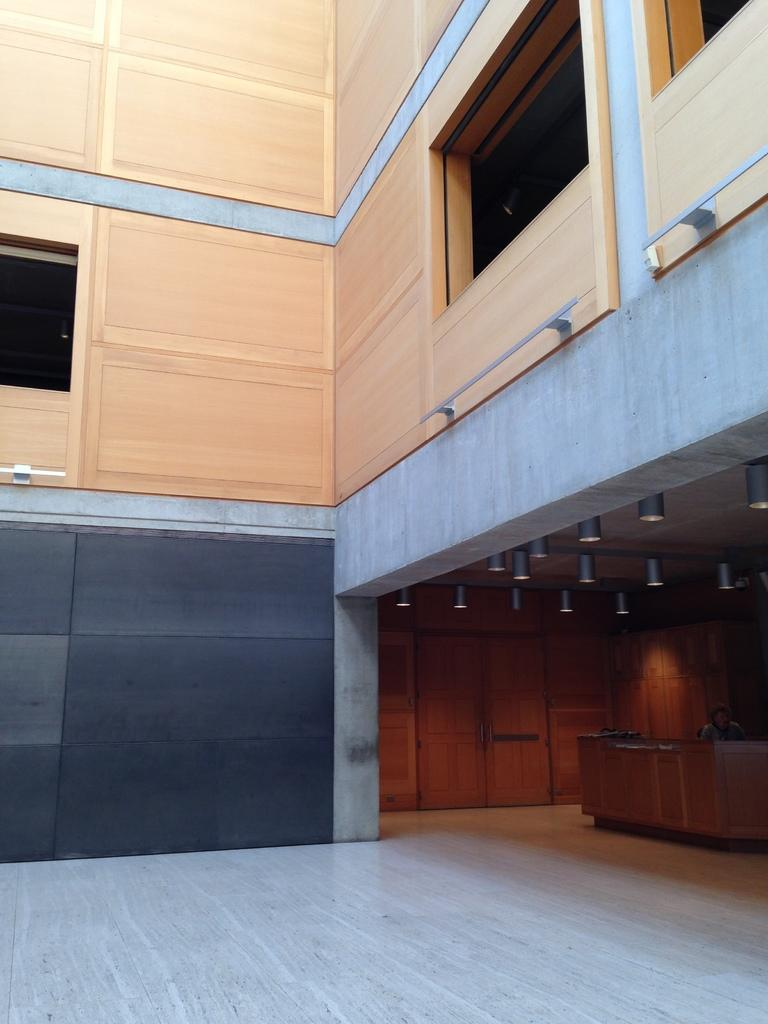What type of material is used for the wall in the image? There is a wooden wall in the image. What can be seen on the wall in the image? There are glass windows in the image. What is present to provide illumination in the image? There are lights in the image. How can one enter or exit the room in the image? There is a door in the image. What piece of furniture is present in the image? There is a desk in the image. Who is present in the image? There is a person in the image. What type of comb is used by the person in the image? There is no comb visible in the image, and the person's hair does not appear to be combed. What color is the ink used by the person in the image? There is no indication of writing or ink in the image. 